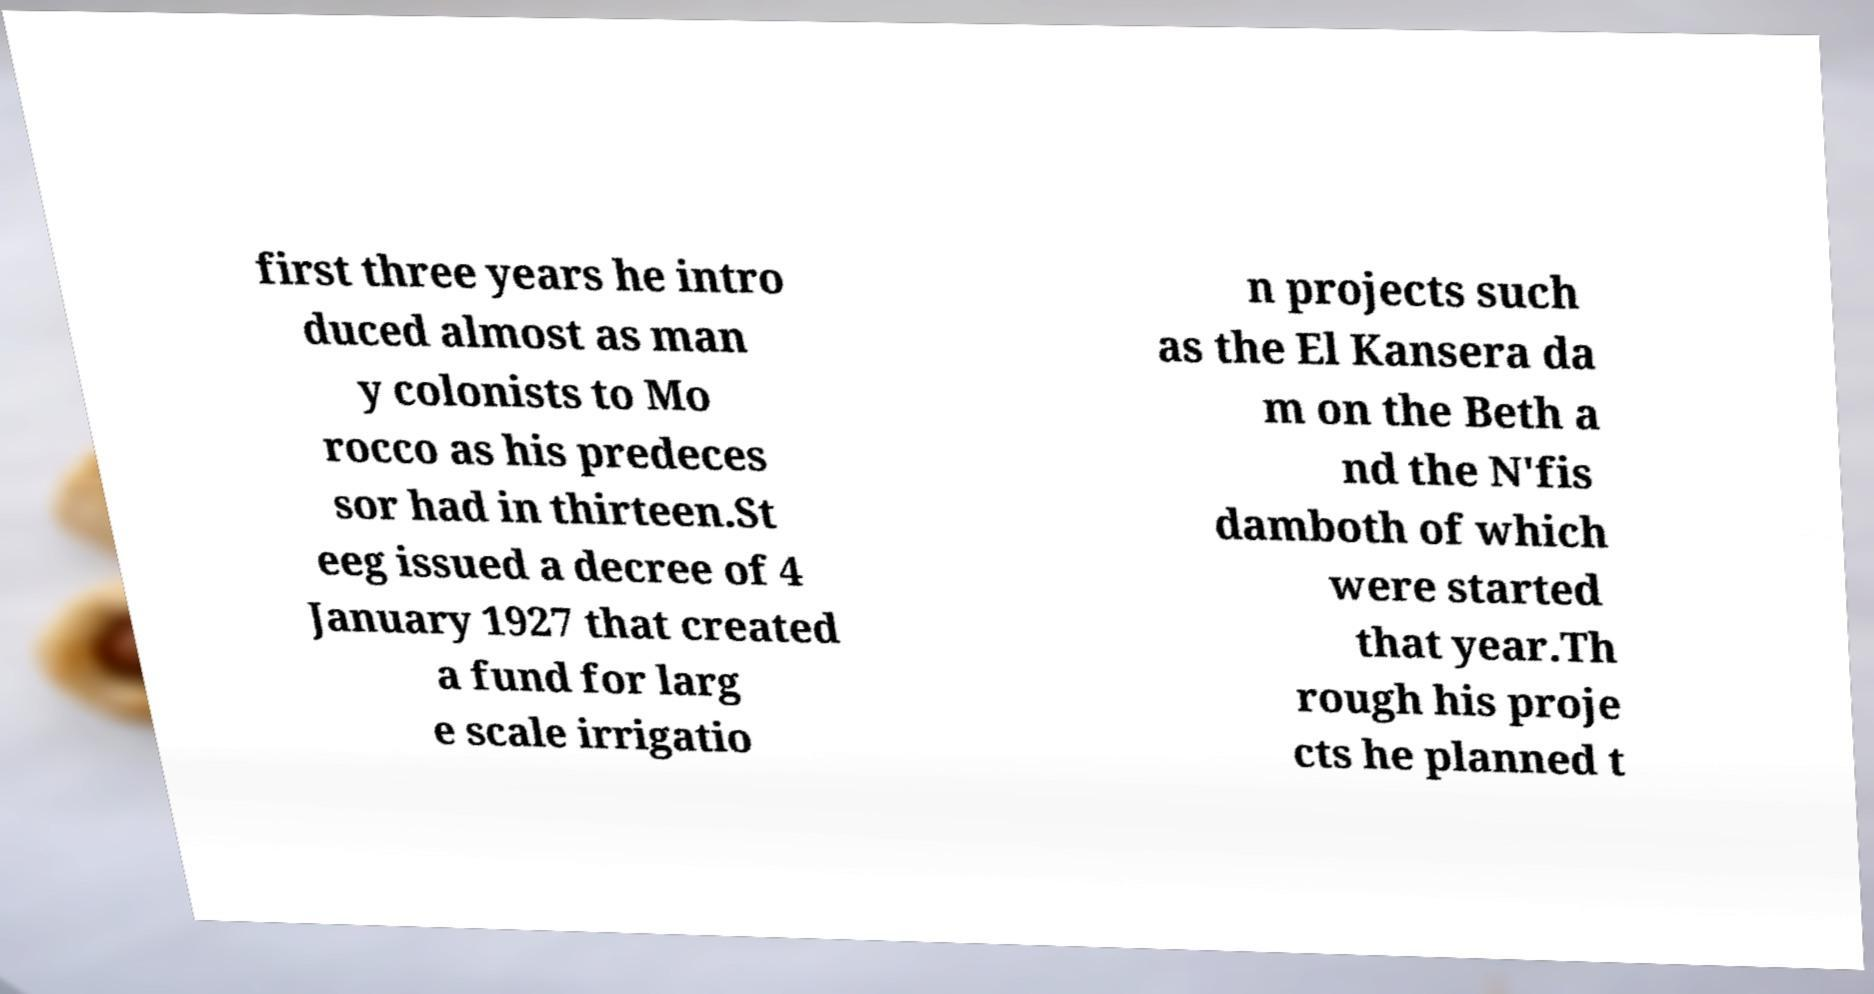For documentation purposes, I need the text within this image transcribed. Could you provide that? first three years he intro duced almost as man y colonists to Mo rocco as his predeces sor had in thirteen.St eeg issued a decree of 4 January 1927 that created a fund for larg e scale irrigatio n projects such as the El Kansera da m on the Beth a nd the N'fis damboth of which were started that year.Th rough his proje cts he planned t 